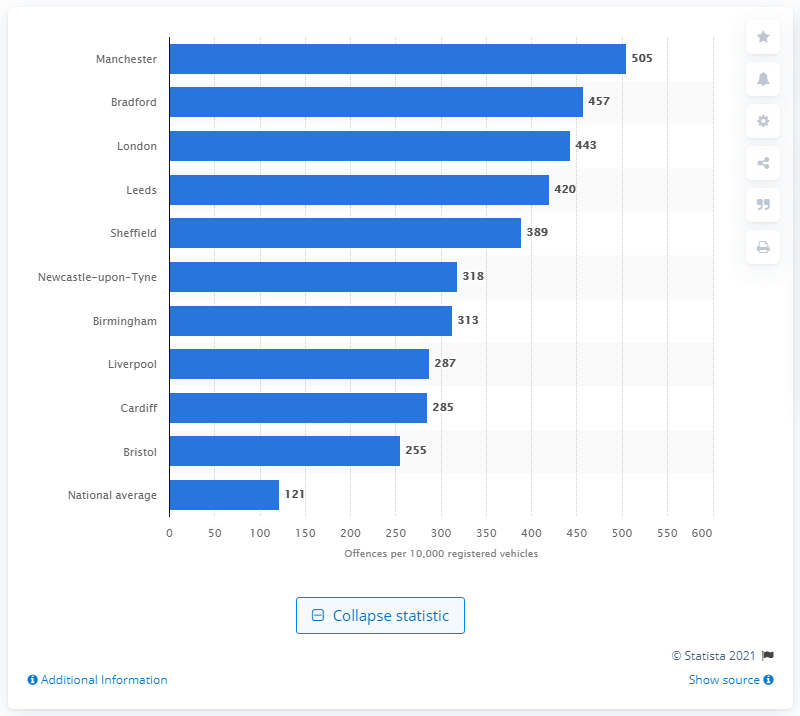Mention a couple of crucial points in this snapshot. The national average for cars stolen per 10,000 registered is 121. Bradford is a city with a high rate of car theft and other forms of car crime. Manchester has the highest car crime rate in the country. 